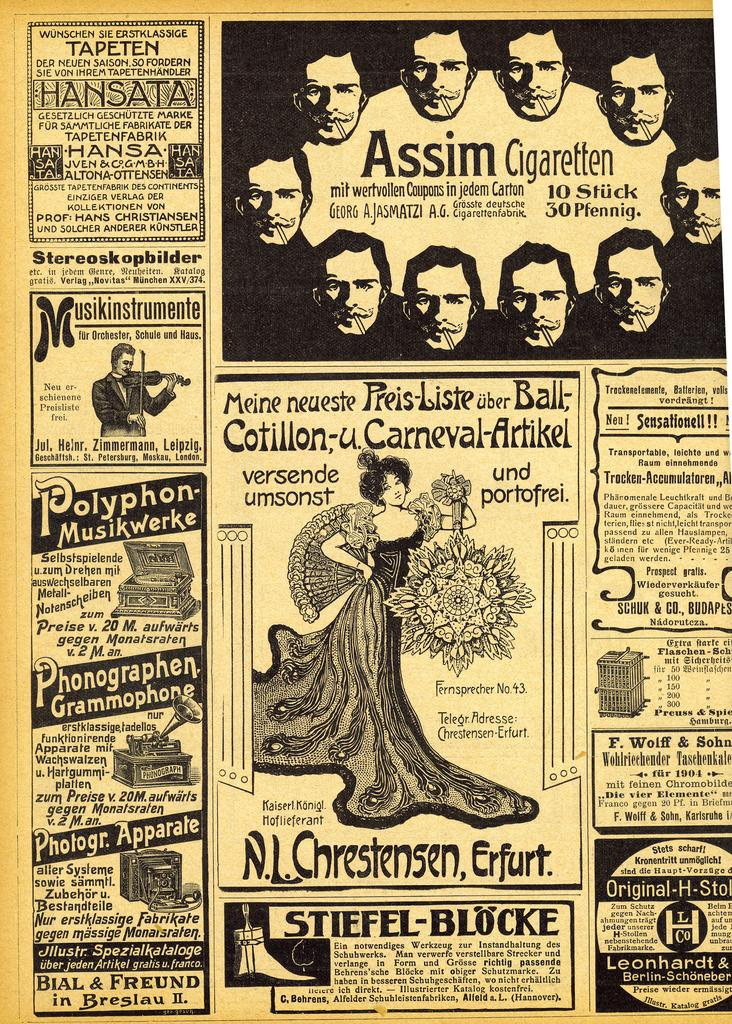<image>
Summarize the visual content of the image. yellowed page of business ads for assim cigaretten, n.l.chrestensen, stiefel-blocke. and others 